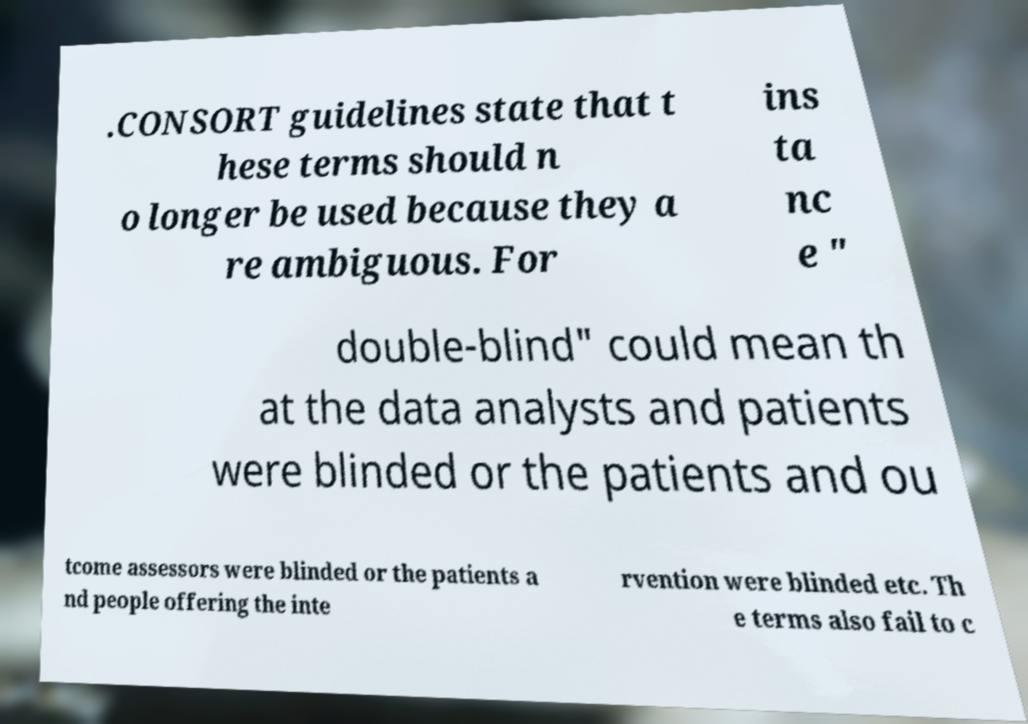Please identify and transcribe the text found in this image. .CONSORT guidelines state that t hese terms should n o longer be used because they a re ambiguous. For ins ta nc e " double-blind" could mean th at the data analysts and patients were blinded or the patients and ou tcome assessors were blinded or the patients a nd people offering the inte rvention were blinded etc. Th e terms also fail to c 